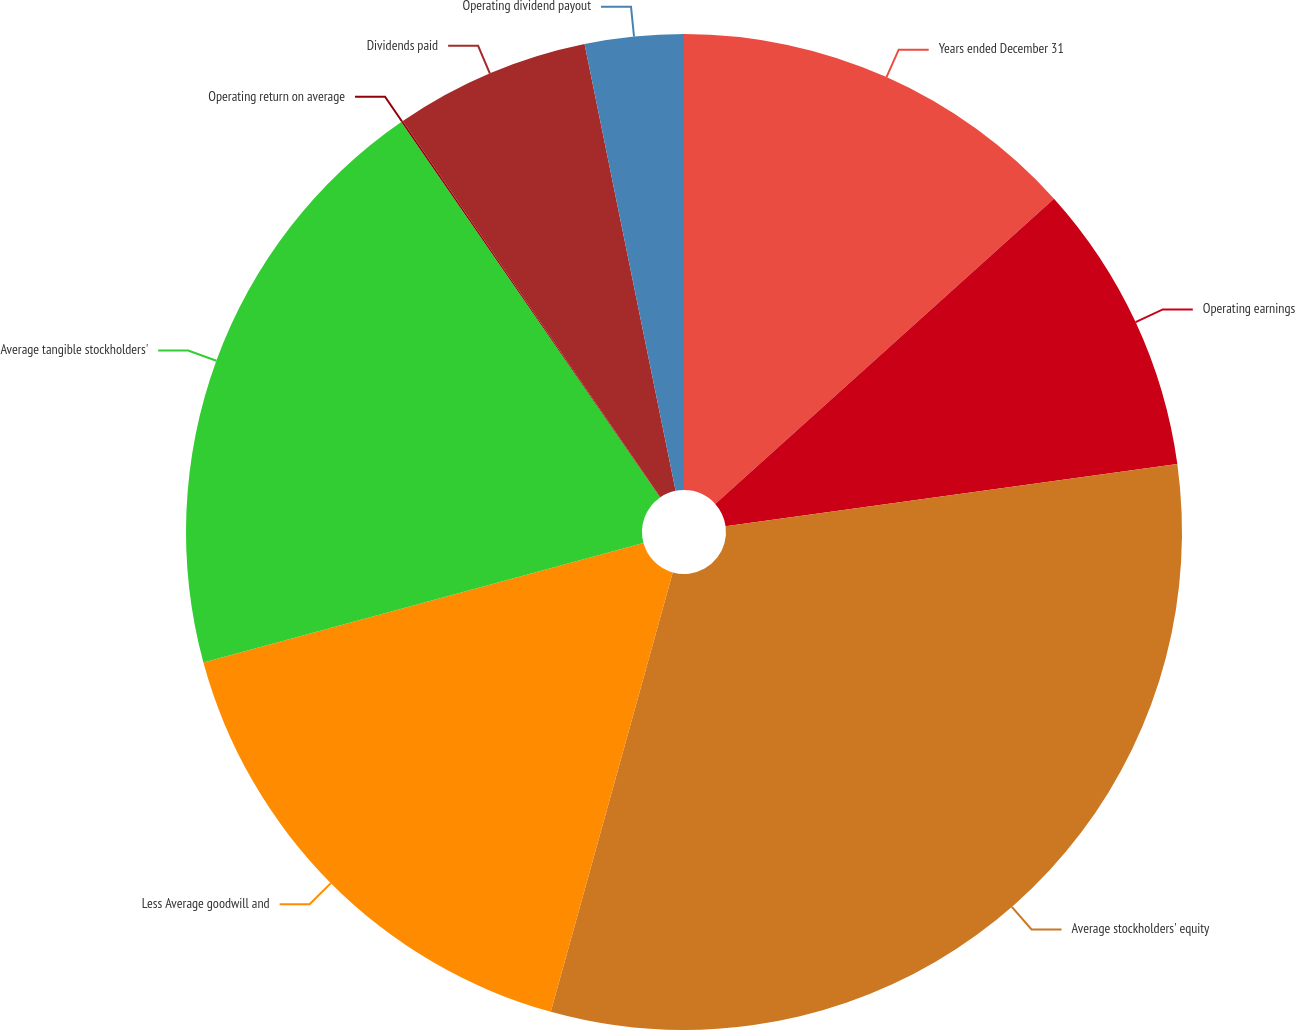Convert chart to OTSL. <chart><loc_0><loc_0><loc_500><loc_500><pie_chart><fcel>Years ended December 31<fcel>Operating earnings<fcel>Average stockholders' equity<fcel>Less Average goodwill and<fcel>Average tangible stockholders'<fcel>Operating return on average<fcel>Dividends paid<fcel>Operating dividend payout<nl><fcel>13.33%<fcel>9.49%<fcel>31.49%<fcel>16.47%<fcel>19.61%<fcel>0.06%<fcel>6.35%<fcel>3.2%<nl></chart> 